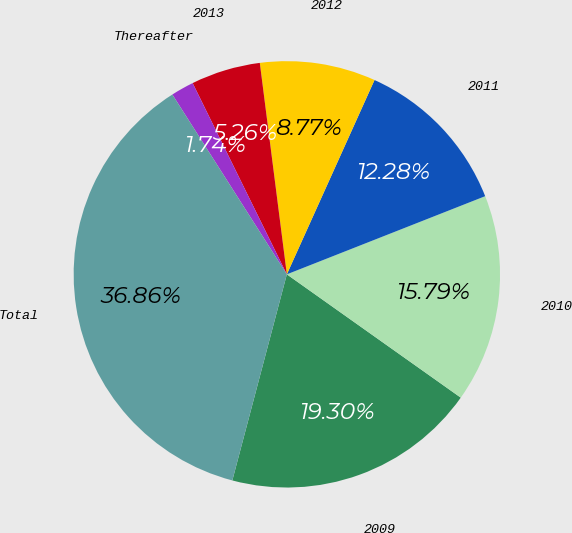<chart> <loc_0><loc_0><loc_500><loc_500><pie_chart><fcel>2009<fcel>2010<fcel>2011<fcel>2012<fcel>2013<fcel>Thereafter<fcel>Total<nl><fcel>19.3%<fcel>15.79%<fcel>12.28%<fcel>8.77%<fcel>5.26%<fcel>1.74%<fcel>36.86%<nl></chart> 